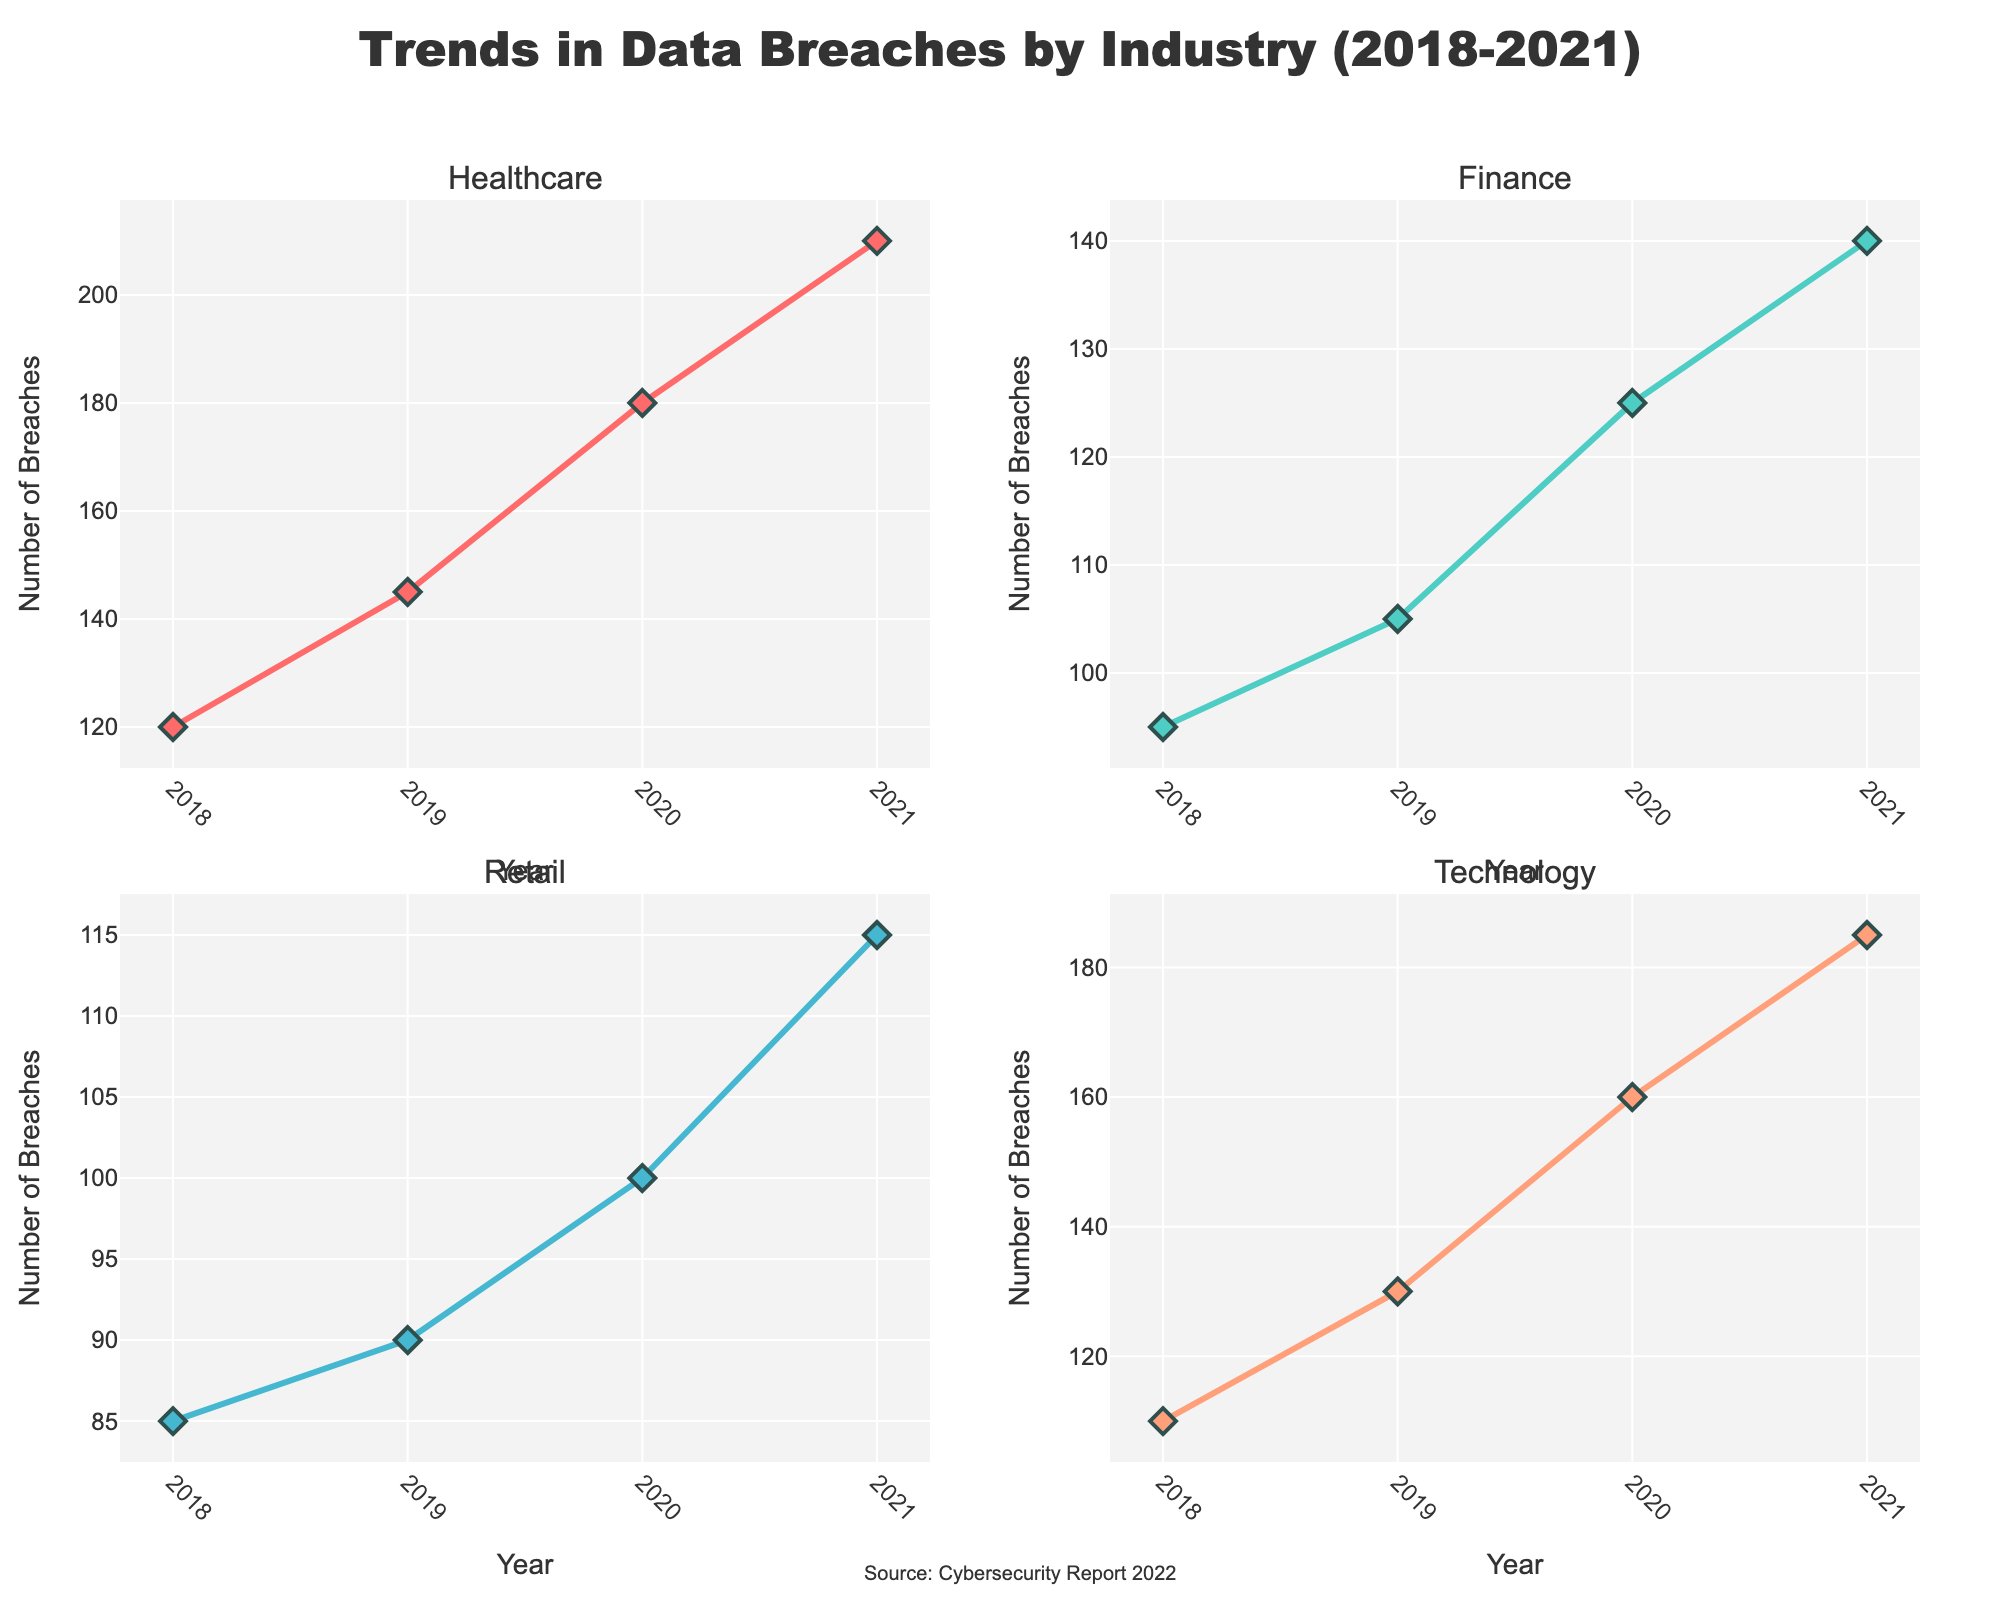How many breaches were reported in the Healthcare sector in 2019? Looking at the subplot for Healthcare, trace the data point for the year 2019 on the x-axis and read the corresponding value on the y-axis.
Answer: 145 What industry experienced the highest number of breaches in 2020? Compare the y-values for all subplots in 2020. The Technology industry shows the highest value.
Answer: Technology Between which years do we see the largest increase in data breaches for the Finance sector? Observe the Finance subplot. Calculate the differences between consecutive years and identify the largest increase: 2018 to 2019 (10), 2019 to 2020 (20), 2020 to 2021 (15). The largest is from 2019 to 2020.
Answer: 2019 to 2020 What is the trend in the number of breaches in the Retail sector from 2018 to 2021? Observe the Retail subplot. The trend shows a gradual increase from 2018 to 2021.
Answer: Increasing How many total data breaches were reported across all industries in 2021? Sum the y-values for all subplots in 2021: Healthcare (210) + Finance (140) + Retail (115) + Technology (185) = 650.
Answer: 650 Which industry saw the most consistent yearly increase in breaches from 2018 to 2021? Examine all subplots to find the industry with a consistent upward trend. Healthcare shows a steady increase yearly.
Answer: Healthcare What was the percentage increase in breaches for the Technology industry from 2020 to 2021? Calculate the difference in breaches between 2020 and 2021 for Technology (185 - 160 = 25). Then, divide by the 2020 value and multiply by 100: (25/160) * 100 ≈ 15.63%.
Answer: 15.63% How does the number of breaches in Finance in 2021 compare to Retail in 2021? Compare the y-values for 2021 in the Finance and Retail subplots. Finance (140) is higher than Retail (115).
Answer: Higher Which year had the highest total number of breaches reported across all industries? Sum the y-values for each year across all subplots and compare: 2018 (410), 2019 (470), 2020 (565), 2021 (650). 2021 has the highest total.
Answer: 2021 